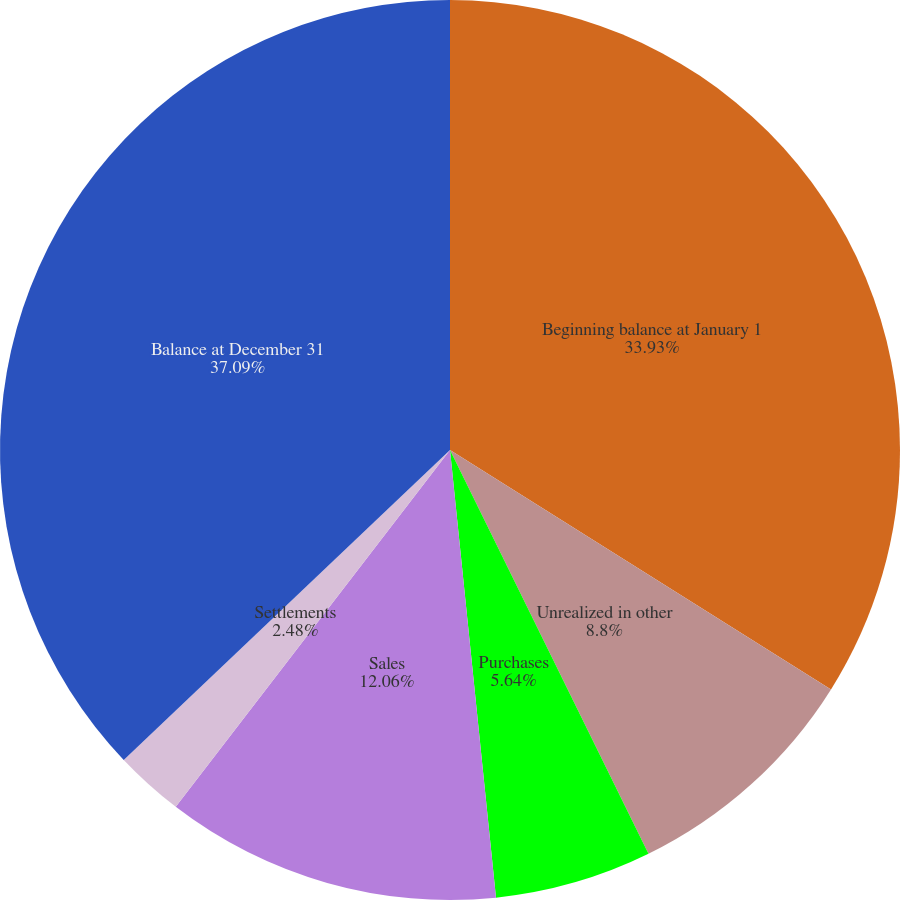Convert chart to OTSL. <chart><loc_0><loc_0><loc_500><loc_500><pie_chart><fcel>Beginning balance at January 1<fcel>Unrealized in other<fcel>Purchases<fcel>Sales<fcel>Settlements<fcel>Balance at December 31<nl><fcel>33.93%<fcel>8.8%<fcel>5.64%<fcel>12.06%<fcel>2.48%<fcel>37.09%<nl></chart> 